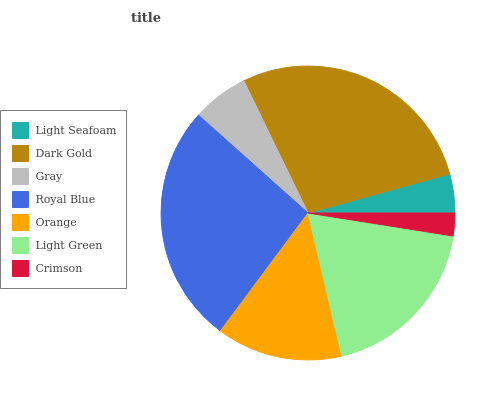Is Crimson the minimum?
Answer yes or no. Yes. Is Dark Gold the maximum?
Answer yes or no. Yes. Is Gray the minimum?
Answer yes or no. No. Is Gray the maximum?
Answer yes or no. No. Is Dark Gold greater than Gray?
Answer yes or no. Yes. Is Gray less than Dark Gold?
Answer yes or no. Yes. Is Gray greater than Dark Gold?
Answer yes or no. No. Is Dark Gold less than Gray?
Answer yes or no. No. Is Orange the high median?
Answer yes or no. Yes. Is Orange the low median?
Answer yes or no. Yes. Is Gray the high median?
Answer yes or no. No. Is Royal Blue the low median?
Answer yes or no. No. 